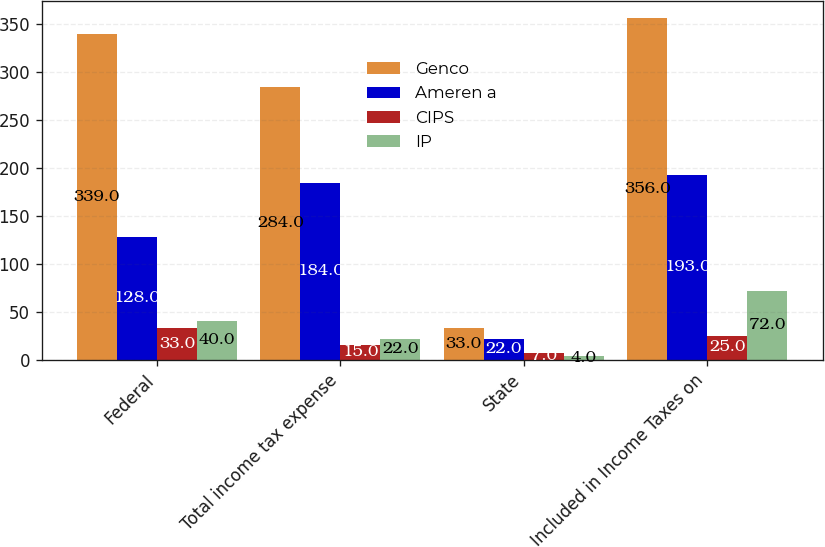<chart> <loc_0><loc_0><loc_500><loc_500><stacked_bar_chart><ecel><fcel>Federal<fcel>Total income tax expense<fcel>State<fcel>Included in Income Taxes on<nl><fcel>Genco<fcel>339<fcel>284<fcel>33<fcel>356<nl><fcel>Ameren a<fcel>128<fcel>184<fcel>22<fcel>193<nl><fcel>CIPS<fcel>33<fcel>15<fcel>7<fcel>25<nl><fcel>IP<fcel>40<fcel>22<fcel>4<fcel>72<nl></chart> 